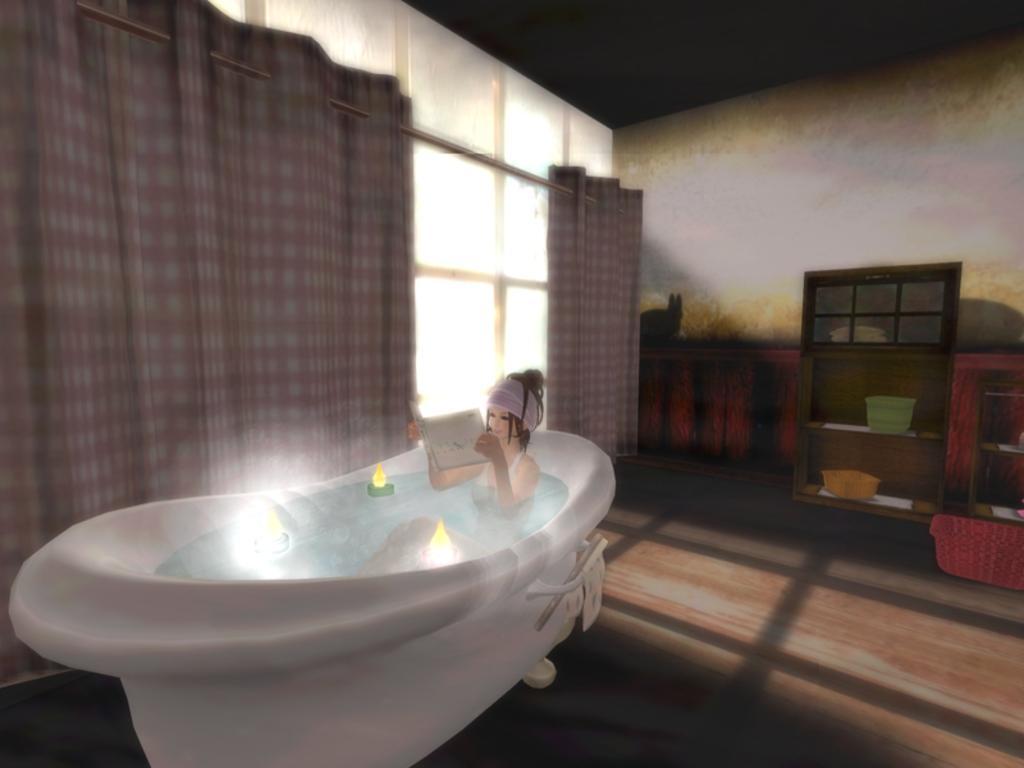Could you give a brief overview of what you see in this image? As we can see in the image there is a woman holding book and sitting on bathtub. There is a wall, curtains, windows, shelves, trays and a tub. 